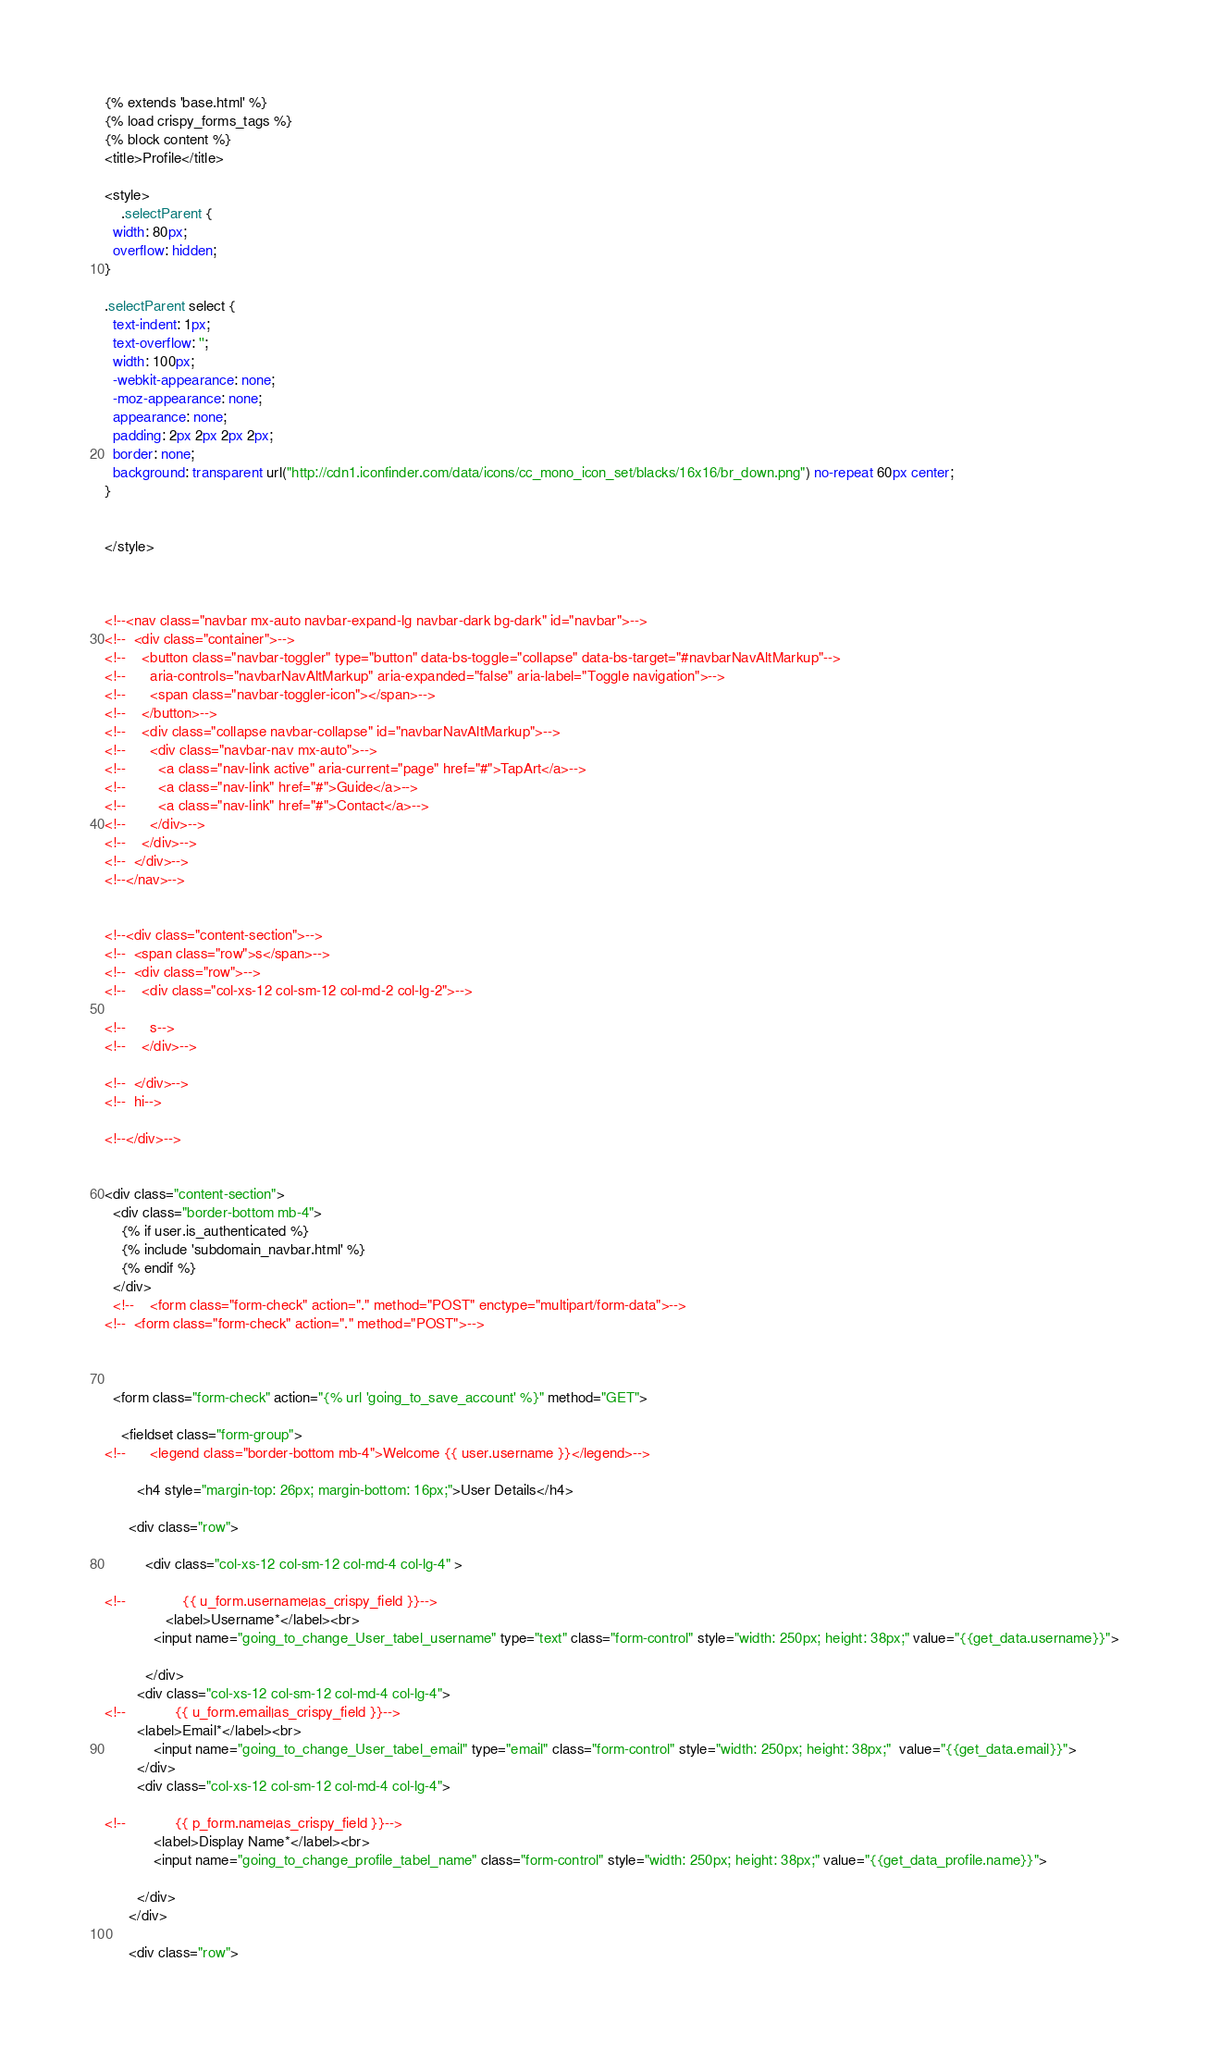Convert code to text. <code><loc_0><loc_0><loc_500><loc_500><_HTML_>{% extends 'base.html' %}
{% load crispy_forms_tags %}
{% block content %}
<title>Profile</title>

<style>
    .selectParent {
  width: 80px;
  overflow: hidden;
}

.selectParent select {
  text-indent: 1px;
  text-overflow: '';
  width: 100px;
  -webkit-appearance: none;
  -moz-appearance: none;
  appearance: none;
  padding: 2px 2px 2px 2px;
  border: none;
  background: transparent url("http://cdn1.iconfinder.com/data/icons/cc_mono_icon_set/blacks/16x16/br_down.png") no-repeat 60px center;
}


</style>



<!--<nav class="navbar mx-auto navbar-expand-lg navbar-dark bg-dark" id="navbar">-->
<!--  <div class="container">-->
<!--    <button class="navbar-toggler" type="button" data-bs-toggle="collapse" data-bs-target="#navbarNavAltMarkup"-->
<!--      aria-controls="navbarNavAltMarkup" aria-expanded="false" aria-label="Toggle navigation">-->
<!--      <span class="navbar-toggler-icon"></span>-->
<!--    </button>-->
<!--    <div class="collapse navbar-collapse" id="navbarNavAltMarkup">-->
<!--      <div class="navbar-nav mx-auto">-->
<!--        <a class="nav-link active" aria-current="page" href="#">TapArt</a>-->
<!--        <a class="nav-link" href="#">Guide</a>-->
<!--        <a class="nav-link" href="#">Contact</a>-->
<!--      </div>-->
<!--    </div>-->
<!--  </div>-->
<!--</nav>-->


<!--<div class="content-section">-->
<!--  <span class="row">s</span>-->
<!--  <div class="row">-->
<!--    <div class="col-xs-12 col-sm-12 col-md-2 col-lg-2">-->

<!--      s-->
<!--    </div>-->

<!--  </div>-->
<!--  hi-->

<!--</div>-->


<div class="content-section">
  <div class="border-bottom mb-4">
    {% if user.is_authenticated %}
    {% include 'subdomain_navbar.html' %}
    {% endif %}
  </div>
  <!--    <form class="form-check" action="." method="POST" enctype="multipart/form-data">-->
<!--  <form class="form-check" action="." method="POST">-->



  <form class="form-check" action="{% url 'going_to_save_account' %}" method="GET">

    <fieldset class="form-group">
<!--      <legend class="border-bottom mb-4">Welcome {{ user.username }}</legend>-->

        <h4 style="margin-top: 26px; margin-bottom: 16px;">User Details</h4>

      <div class="row">

          <div class="col-xs-12 col-sm-12 col-md-4 col-lg-4" >

<!--              {{ u_form.username|as_crispy_field }}-->
               <label>Username*</label><br>
            <input name="going_to_change_User_tabel_username" type="text" class="form-control" style="width: 250px; height: 38px;" value="{{get_data.username}}">

          </div>
        <div class="col-xs-12 col-sm-12 col-md-4 col-lg-4">
<!--            {{ u_form.email|as_crispy_field }}-->
        <label>Email*</label><br>
            <input name="going_to_change_User_tabel_email" type="email" class="form-control" style="width: 250px; height: 38px;"  value="{{get_data.email}}">
        </div>
        <div class="col-xs-12 col-sm-12 col-md-4 col-lg-4">

<!--            {{ p_form.name|as_crispy_field }}-->
            <label>Display Name*</label><br>
            <input name="going_to_change_profile_tabel_name" class="form-control" style="width: 250px; height: 38px;" value="{{get_data_profile.name}}">

        </div>
      </div>

      <div class="row"></code> 